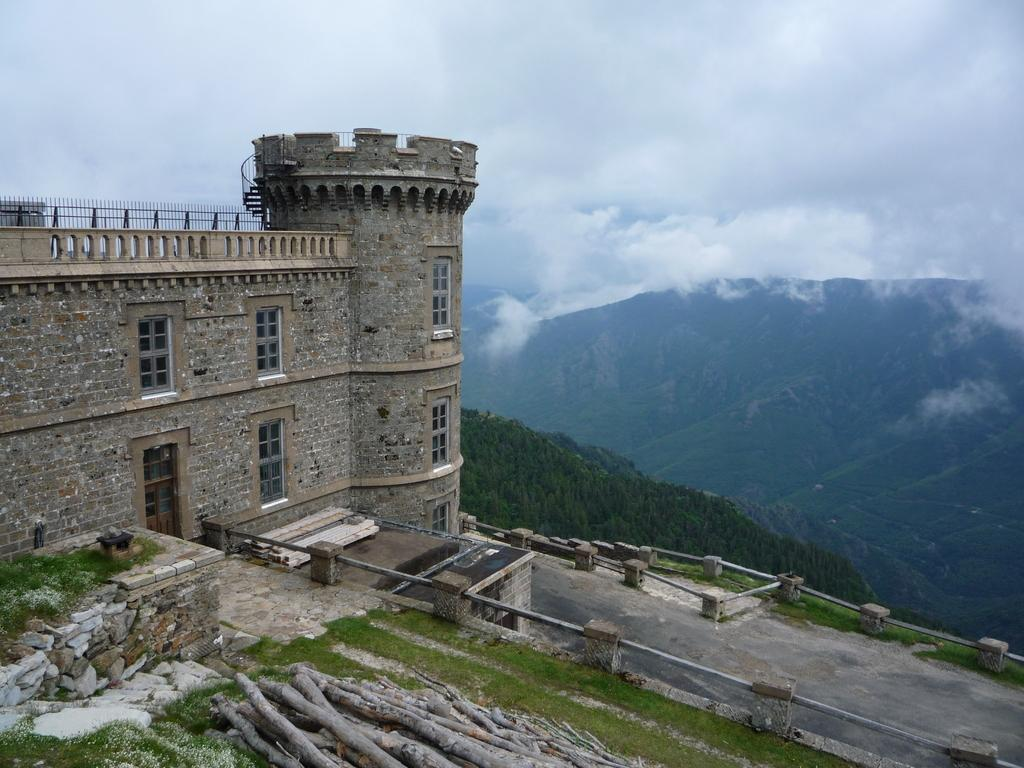What type of structure is visible in the image? There is a building in the image. What other natural elements can be seen in the image? There are plants, trees, and mountains visible in the image. What objects are present in the image? There are wooden sticks and a fence in the image. What is visible in the sky in the image? The sky is visible in the image, and clouds are present. What type of bath can be seen in the image? There is no bath present in the image. What season is depicted in the image? The provided facts do not indicate a specific season, so it cannot be determined from the image. 